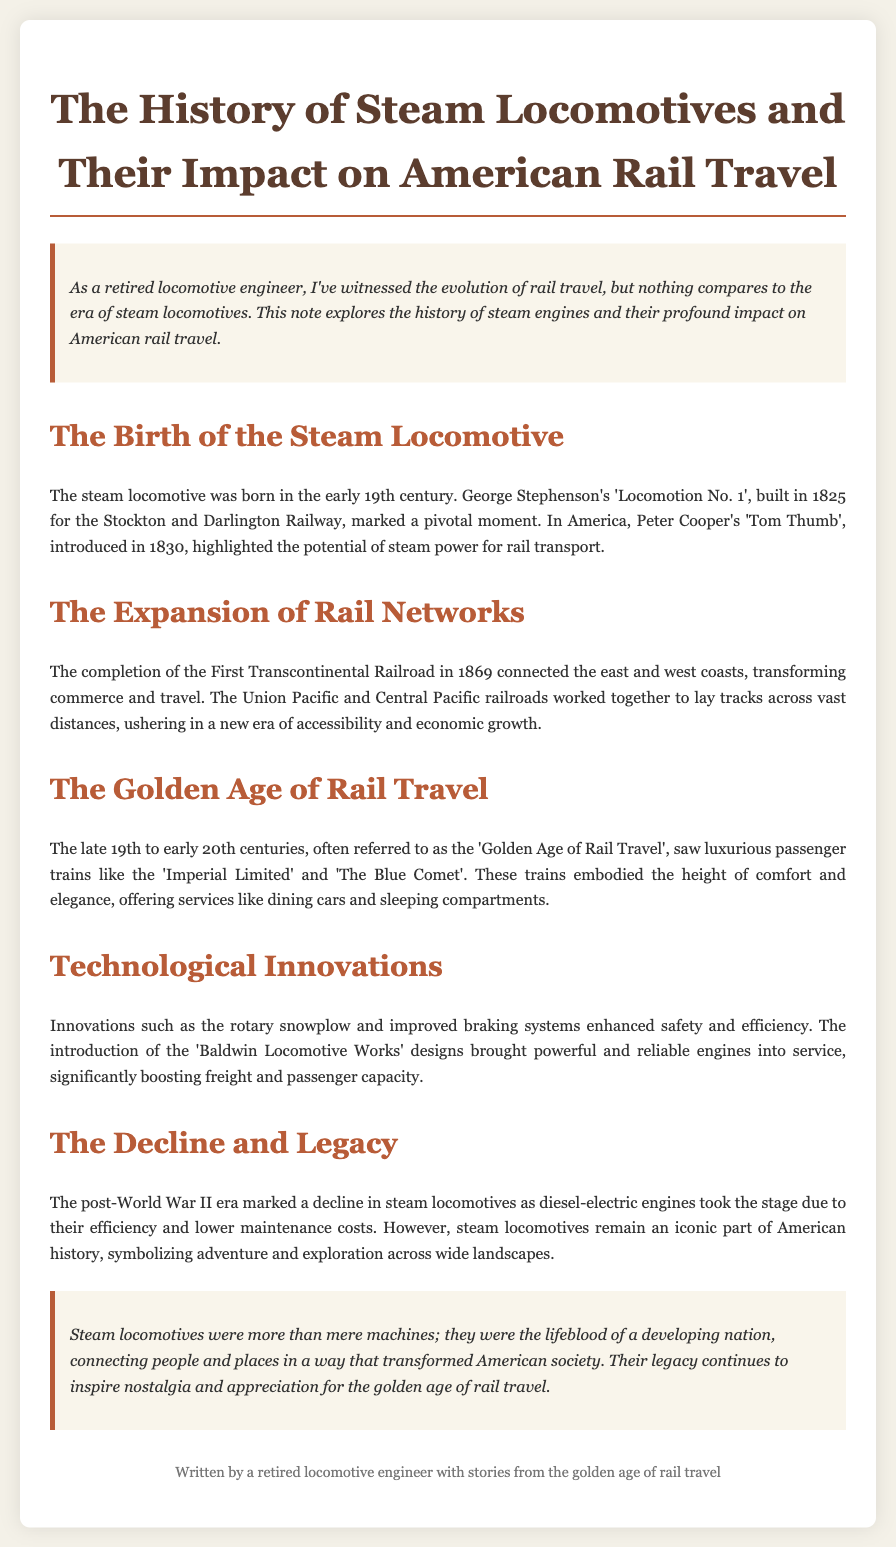What year was the steam locomotive born? The steam locomotive was born in the early 19th century.
Answer: early 19th century Who built 'Locomotion No. 1'? 'Locomotion No. 1' was built by George Stephenson.
Answer: George Stephenson What significant railroad was completed in 1869? The significant railroad completed in 1869 was the First Transcontinental Railroad.
Answer: First Transcontinental Railroad What is referred to as the 'Golden Age of Rail Travel'? The late 19th to early 20th centuries is referred to as the 'Golden Age of Rail Travel'.
Answer: late 19th to early 20th centuries What technological innovation enhanced safety and efficiency in rail travel? Innovations such as the rotary snowplow enhanced safety and efficiency.
Answer: rotary snowplow What type of engines took over after the decline of steam locomotives? Diesel-electric engines took over after the decline of steam locomotives.
Answer: Diesel-electric engines What iconic symbol does the steam locomotive represent in American history? Steam locomotives symbolize adventure and exploration across wide landscapes.
Answer: adventure and exploration How did the completion of the First Transcontinental Railroad transform commerce? It transformed commerce and travel by connecting the east and west coasts.
Answer: connecting the east and west coasts What is noted as a key feature of luxurious passenger trains during their peak? Luxurious passenger trains offered services like dining cars and sleeping compartments.
Answer: dining cars and sleeping compartments 